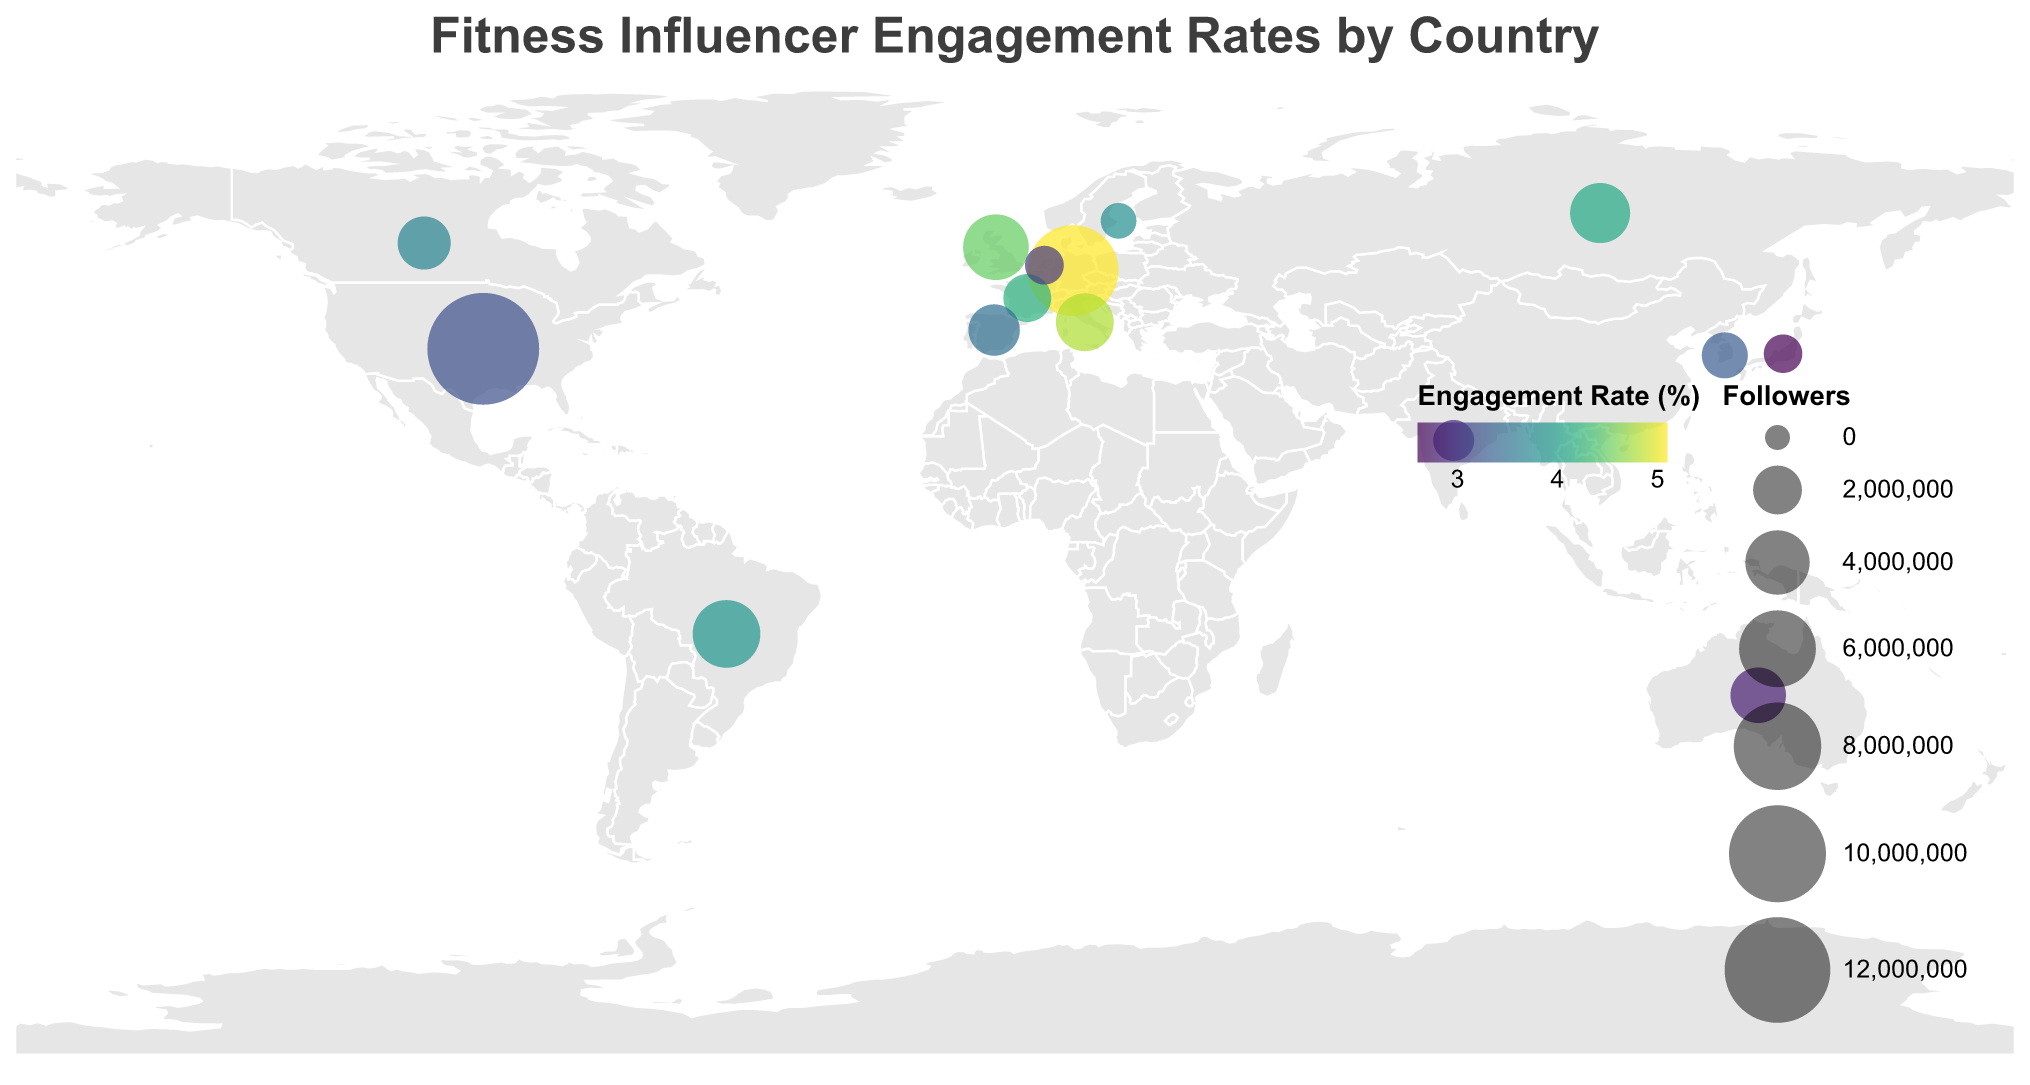What is the title of the plot? The title of the plot is the text at the top which provides an overview of the data being presented. Here, it is written in Arial font and placed in the middle.
Answer: Fitness Influencer Engagement Rates by Country How many data points are displayed on the plot? You can count each circle on the plot, with each representing a different fitness influencer in a distinct country.
Answer: 15 Which influencer has the highest engagement rate? Locate the influencer with the highest numerical value in the 'Engagement Rate' legend, highlighted by the most vibrant color on the plot.
Answer: Pamela Reif Which country has the influencer with the largest number of followers? Locate the largest circle on the plot, which represents the highest number of followers for an influencer.
Answer: United States What is the engagement rate of Joe Wicks from the United Kingdom? Hover over or refer to the tooltip for Joe Wicks to check the engagement rate next to his information.
Answer: 4.5 Which influencer in Europe has the highest engagement rate? Identify the countries that fall within Europe on the plot and then check the engagement rate values for their influencers.
Answer: Pamela Reif (Germany) What is the average engagement rate of influencers from North America? Determine the engagement rates of influencers from the United States and Canada, and then calculate their average value. Kayla Itsines (3.2) from United States and Kelsey Wells (3.7) from Canada. Average = (3.2 + 3.7) / 2 = 3.45.
Answer: 3.45 Compare the follower counts between Gabriela Pugliesi and Yasmin Karachiwala. Who has more followers? Identify their respective positions on the plot and refer to their follower counts. Gabriela Pugliesi has 4,500,000 followers and Yasmin Karachiwala has 1,200,000 followers.
Answer: Gabriela Pugliesi How does the engagement rate of RIE FIT in Japan compare to that of Joo Chae Rin in South Korea? Locate both countries and refer to the engagement rates of their respective influencers from the tooltips. RIE FIT has 2.6% and Joo Chae Rin has 3.3%.
Answer: RIE FIT has a lower engagement rate than Joo Chae Rin Which influencer in the plot has the smallest number of followers, and what is their engagement rate? Find the smallest circle on the plot which indicates the least number of followers; check the tooltip for the engagement rate. Denice Moberg from Sweden has 750,000 followers with an engagement rate of 3.8%.
Answer: Denice Moberg, 3.8 